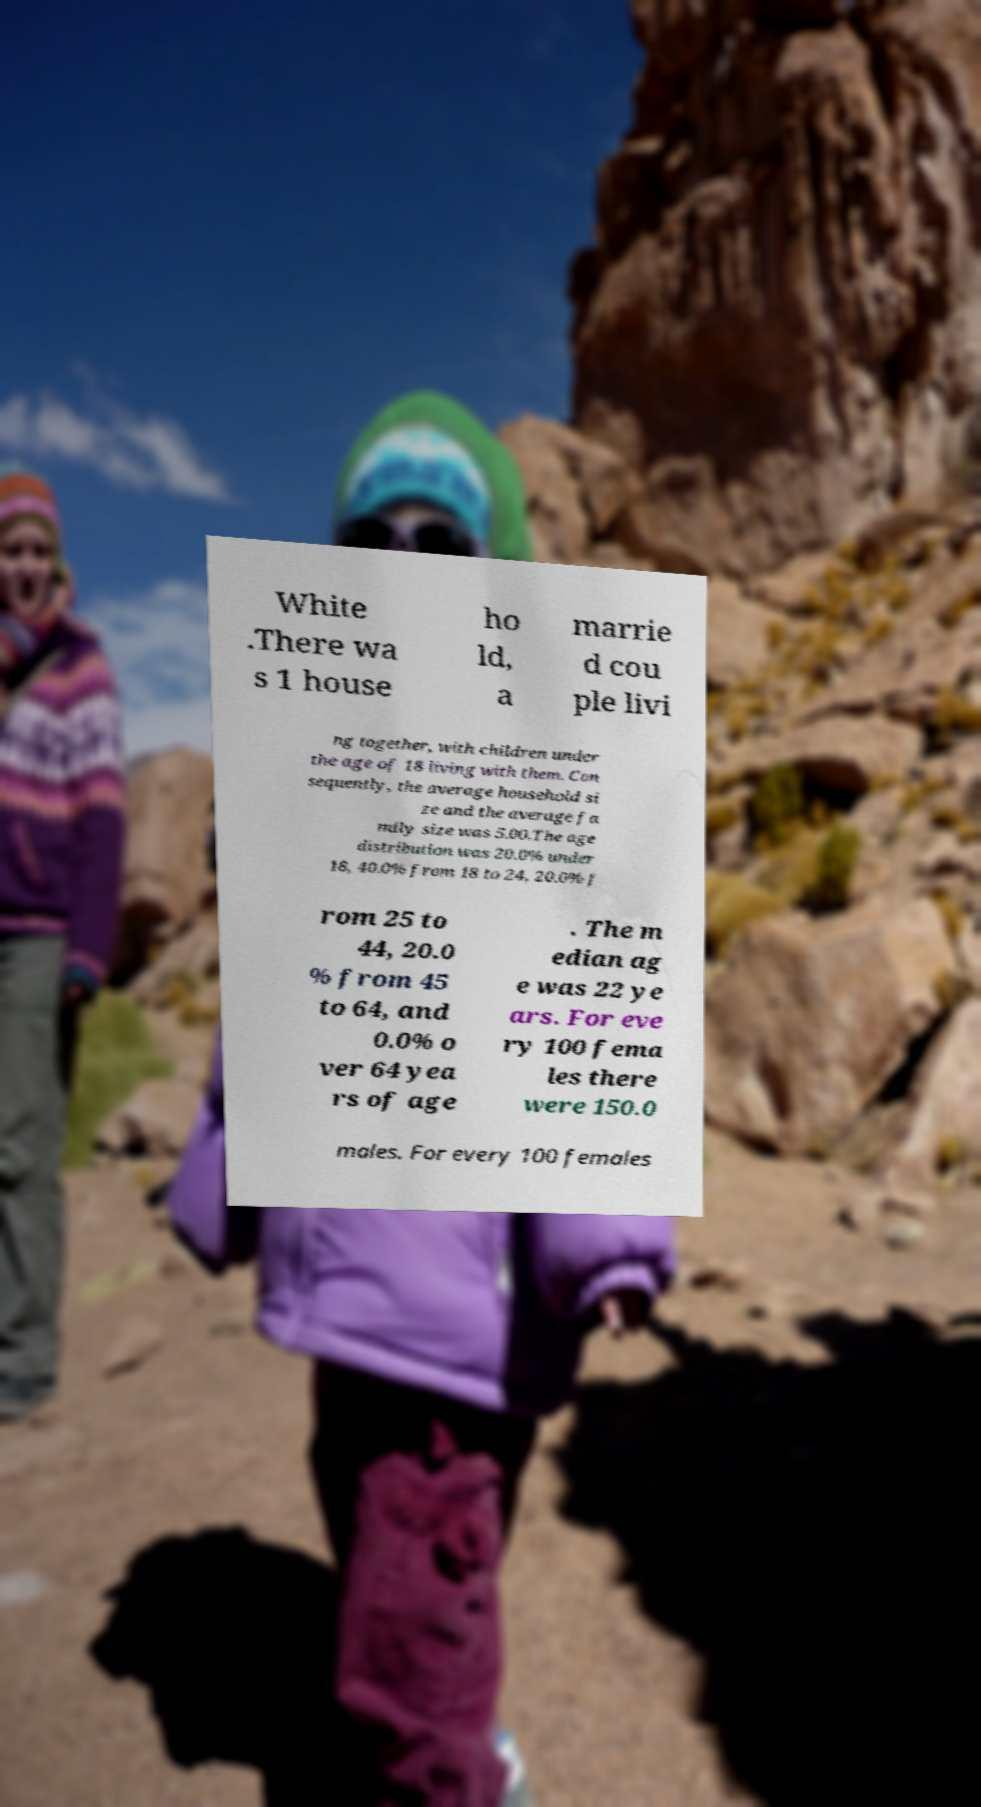Could you assist in decoding the text presented in this image and type it out clearly? White .There wa s 1 house ho ld, a marrie d cou ple livi ng together, with children under the age of 18 living with them. Con sequently, the average household si ze and the average fa mily size was 5.00.The age distribution was 20.0% under 18, 40.0% from 18 to 24, 20.0% f rom 25 to 44, 20.0 % from 45 to 64, and 0.0% o ver 64 yea rs of age . The m edian ag e was 22 ye ars. For eve ry 100 fema les there were 150.0 males. For every 100 females 